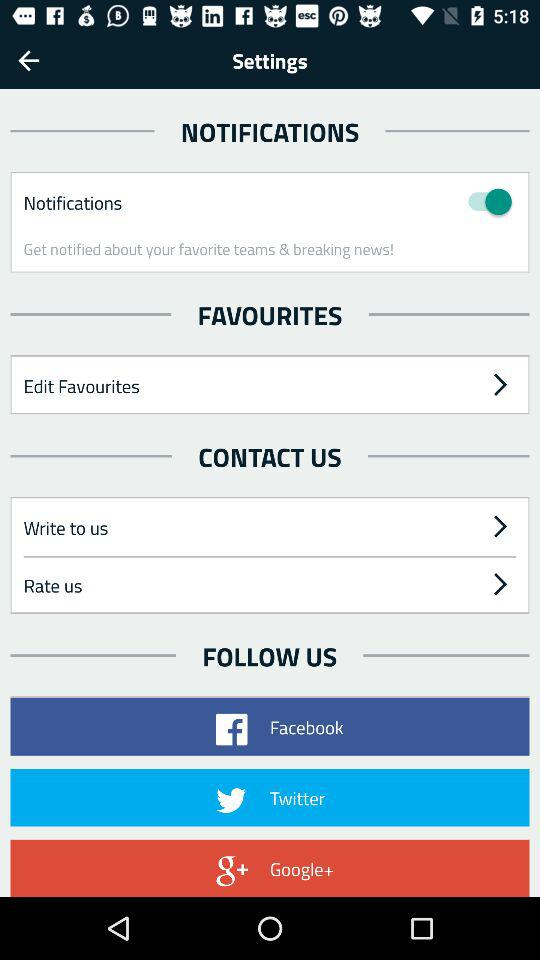What is the status of the "Notifications"? The status is on. 